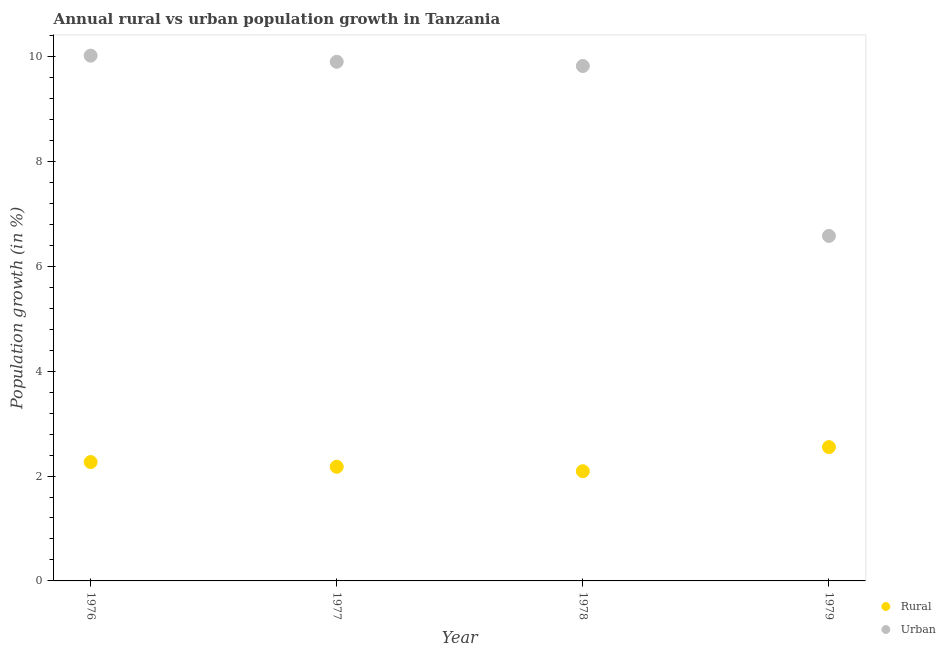What is the rural population growth in 1976?
Give a very brief answer. 2.27. Across all years, what is the maximum rural population growth?
Your answer should be very brief. 2.55. Across all years, what is the minimum urban population growth?
Give a very brief answer. 6.58. In which year was the urban population growth maximum?
Provide a succinct answer. 1976. In which year was the urban population growth minimum?
Give a very brief answer. 1979. What is the total urban population growth in the graph?
Keep it short and to the point. 36.32. What is the difference between the rural population growth in 1976 and that in 1978?
Offer a terse response. 0.17. What is the difference between the rural population growth in 1976 and the urban population growth in 1977?
Your answer should be compact. -7.63. What is the average urban population growth per year?
Ensure brevity in your answer.  9.08. In the year 1976, what is the difference between the urban population growth and rural population growth?
Offer a very short reply. 7.75. In how many years, is the urban population growth greater than 2.8 %?
Keep it short and to the point. 4. What is the ratio of the urban population growth in 1977 to that in 1979?
Your answer should be compact. 1.5. What is the difference between the highest and the second highest urban population growth?
Offer a terse response. 0.12. What is the difference between the highest and the lowest rural population growth?
Your answer should be very brief. 0.46. Is the rural population growth strictly greater than the urban population growth over the years?
Keep it short and to the point. No. How many dotlines are there?
Provide a succinct answer. 2. How many years are there in the graph?
Offer a very short reply. 4. What is the difference between two consecutive major ticks on the Y-axis?
Your answer should be very brief. 2. How are the legend labels stacked?
Offer a very short reply. Vertical. What is the title of the graph?
Offer a terse response. Annual rural vs urban population growth in Tanzania. Does "Netherlands" appear as one of the legend labels in the graph?
Your answer should be compact. No. What is the label or title of the Y-axis?
Offer a terse response. Population growth (in %). What is the Population growth (in %) in Rural in 1976?
Give a very brief answer. 2.27. What is the Population growth (in %) of Urban  in 1976?
Make the answer very short. 10.02. What is the Population growth (in %) of Rural in 1977?
Your answer should be very brief. 2.18. What is the Population growth (in %) of Urban  in 1977?
Ensure brevity in your answer.  9.9. What is the Population growth (in %) of Rural in 1978?
Provide a short and direct response. 2.09. What is the Population growth (in %) in Urban  in 1978?
Provide a succinct answer. 9.82. What is the Population growth (in %) of Rural in 1979?
Offer a very short reply. 2.55. What is the Population growth (in %) of Urban  in 1979?
Ensure brevity in your answer.  6.58. Across all years, what is the maximum Population growth (in %) in Rural?
Provide a succinct answer. 2.55. Across all years, what is the maximum Population growth (in %) of Urban ?
Provide a succinct answer. 10.02. Across all years, what is the minimum Population growth (in %) in Rural?
Keep it short and to the point. 2.09. Across all years, what is the minimum Population growth (in %) of Urban ?
Provide a succinct answer. 6.58. What is the total Population growth (in %) of Rural in the graph?
Make the answer very short. 9.09. What is the total Population growth (in %) of Urban  in the graph?
Your answer should be very brief. 36.32. What is the difference between the Population growth (in %) in Rural in 1976 and that in 1977?
Your response must be concise. 0.09. What is the difference between the Population growth (in %) in Urban  in 1976 and that in 1977?
Your answer should be compact. 0.12. What is the difference between the Population growth (in %) of Rural in 1976 and that in 1978?
Your answer should be compact. 0.17. What is the difference between the Population growth (in %) in Urban  in 1976 and that in 1978?
Offer a terse response. 0.2. What is the difference between the Population growth (in %) in Rural in 1976 and that in 1979?
Your answer should be very brief. -0.29. What is the difference between the Population growth (in %) of Urban  in 1976 and that in 1979?
Your answer should be very brief. 3.44. What is the difference between the Population growth (in %) in Rural in 1977 and that in 1978?
Provide a succinct answer. 0.08. What is the difference between the Population growth (in %) of Urban  in 1977 and that in 1978?
Your answer should be compact. 0.08. What is the difference between the Population growth (in %) of Rural in 1977 and that in 1979?
Keep it short and to the point. -0.37. What is the difference between the Population growth (in %) of Urban  in 1977 and that in 1979?
Offer a very short reply. 3.32. What is the difference between the Population growth (in %) of Rural in 1978 and that in 1979?
Your answer should be compact. -0.46. What is the difference between the Population growth (in %) in Urban  in 1978 and that in 1979?
Provide a succinct answer. 3.24. What is the difference between the Population growth (in %) of Rural in 1976 and the Population growth (in %) of Urban  in 1977?
Provide a succinct answer. -7.63. What is the difference between the Population growth (in %) of Rural in 1976 and the Population growth (in %) of Urban  in 1978?
Offer a very short reply. -7.55. What is the difference between the Population growth (in %) in Rural in 1976 and the Population growth (in %) in Urban  in 1979?
Keep it short and to the point. -4.31. What is the difference between the Population growth (in %) of Rural in 1977 and the Population growth (in %) of Urban  in 1978?
Give a very brief answer. -7.64. What is the difference between the Population growth (in %) of Rural in 1977 and the Population growth (in %) of Urban  in 1979?
Provide a short and direct response. -4.4. What is the difference between the Population growth (in %) in Rural in 1978 and the Population growth (in %) in Urban  in 1979?
Give a very brief answer. -4.49. What is the average Population growth (in %) of Rural per year?
Provide a short and direct response. 2.27. What is the average Population growth (in %) of Urban  per year?
Give a very brief answer. 9.08. In the year 1976, what is the difference between the Population growth (in %) in Rural and Population growth (in %) in Urban ?
Make the answer very short. -7.75. In the year 1977, what is the difference between the Population growth (in %) in Rural and Population growth (in %) in Urban ?
Your response must be concise. -7.72. In the year 1978, what is the difference between the Population growth (in %) of Rural and Population growth (in %) of Urban ?
Make the answer very short. -7.73. In the year 1979, what is the difference between the Population growth (in %) in Rural and Population growth (in %) in Urban ?
Keep it short and to the point. -4.03. What is the ratio of the Population growth (in %) of Rural in 1976 to that in 1977?
Provide a short and direct response. 1.04. What is the ratio of the Population growth (in %) of Urban  in 1976 to that in 1977?
Your answer should be compact. 1.01. What is the ratio of the Population growth (in %) in Rural in 1976 to that in 1978?
Ensure brevity in your answer.  1.08. What is the ratio of the Population growth (in %) of Urban  in 1976 to that in 1978?
Offer a very short reply. 1.02. What is the ratio of the Population growth (in %) in Rural in 1976 to that in 1979?
Offer a terse response. 0.89. What is the ratio of the Population growth (in %) of Urban  in 1976 to that in 1979?
Offer a terse response. 1.52. What is the ratio of the Population growth (in %) in Rural in 1977 to that in 1978?
Make the answer very short. 1.04. What is the ratio of the Population growth (in %) of Urban  in 1977 to that in 1978?
Ensure brevity in your answer.  1.01. What is the ratio of the Population growth (in %) in Rural in 1977 to that in 1979?
Offer a terse response. 0.85. What is the ratio of the Population growth (in %) of Urban  in 1977 to that in 1979?
Keep it short and to the point. 1.5. What is the ratio of the Population growth (in %) in Rural in 1978 to that in 1979?
Your answer should be compact. 0.82. What is the ratio of the Population growth (in %) of Urban  in 1978 to that in 1979?
Your answer should be compact. 1.49. What is the difference between the highest and the second highest Population growth (in %) in Rural?
Give a very brief answer. 0.29. What is the difference between the highest and the second highest Population growth (in %) in Urban ?
Keep it short and to the point. 0.12. What is the difference between the highest and the lowest Population growth (in %) of Rural?
Give a very brief answer. 0.46. What is the difference between the highest and the lowest Population growth (in %) of Urban ?
Your answer should be compact. 3.44. 